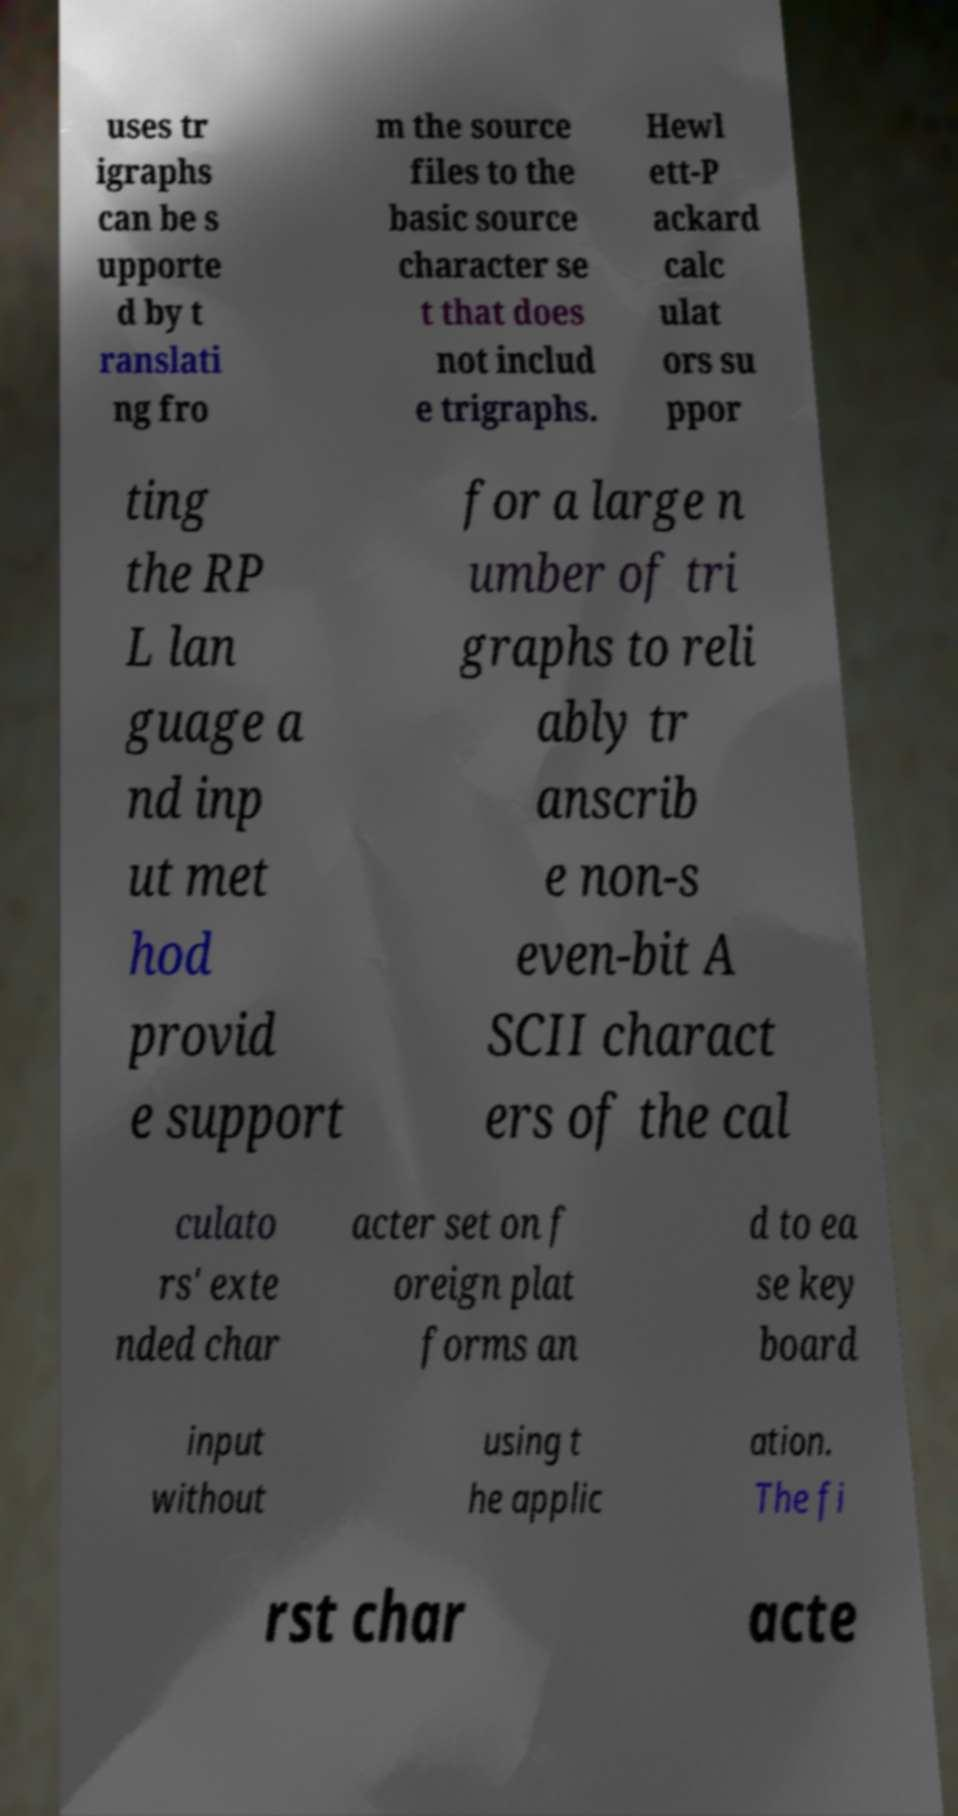Can you read and provide the text displayed in the image?This photo seems to have some interesting text. Can you extract and type it out for me? uses tr igraphs can be s upporte d by t ranslati ng fro m the source files to the basic source character se t that does not includ e trigraphs. Hewl ett-P ackard calc ulat ors su ppor ting the RP L lan guage a nd inp ut met hod provid e support for a large n umber of tri graphs to reli ably tr anscrib e non-s even-bit A SCII charact ers of the cal culato rs' exte nded char acter set on f oreign plat forms an d to ea se key board input without using t he applic ation. The fi rst char acte 